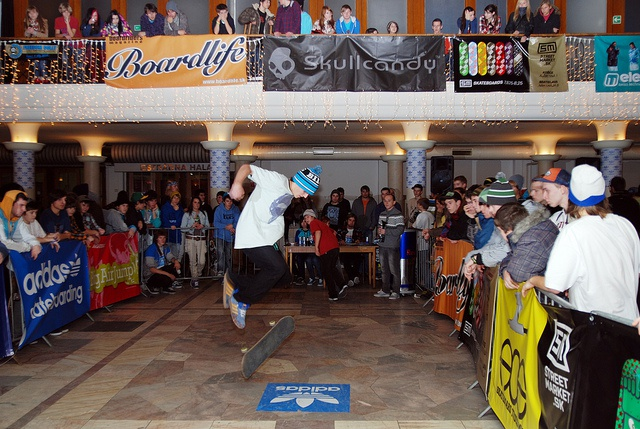Describe the objects in this image and their specific colors. I can see people in gray, black, maroon, and navy tones, people in gray, white, darkgray, black, and maroon tones, people in gray, lightgray, black, darkgray, and lightpink tones, people in gray, darkgray, and black tones, and people in gray, black, and brown tones in this image. 